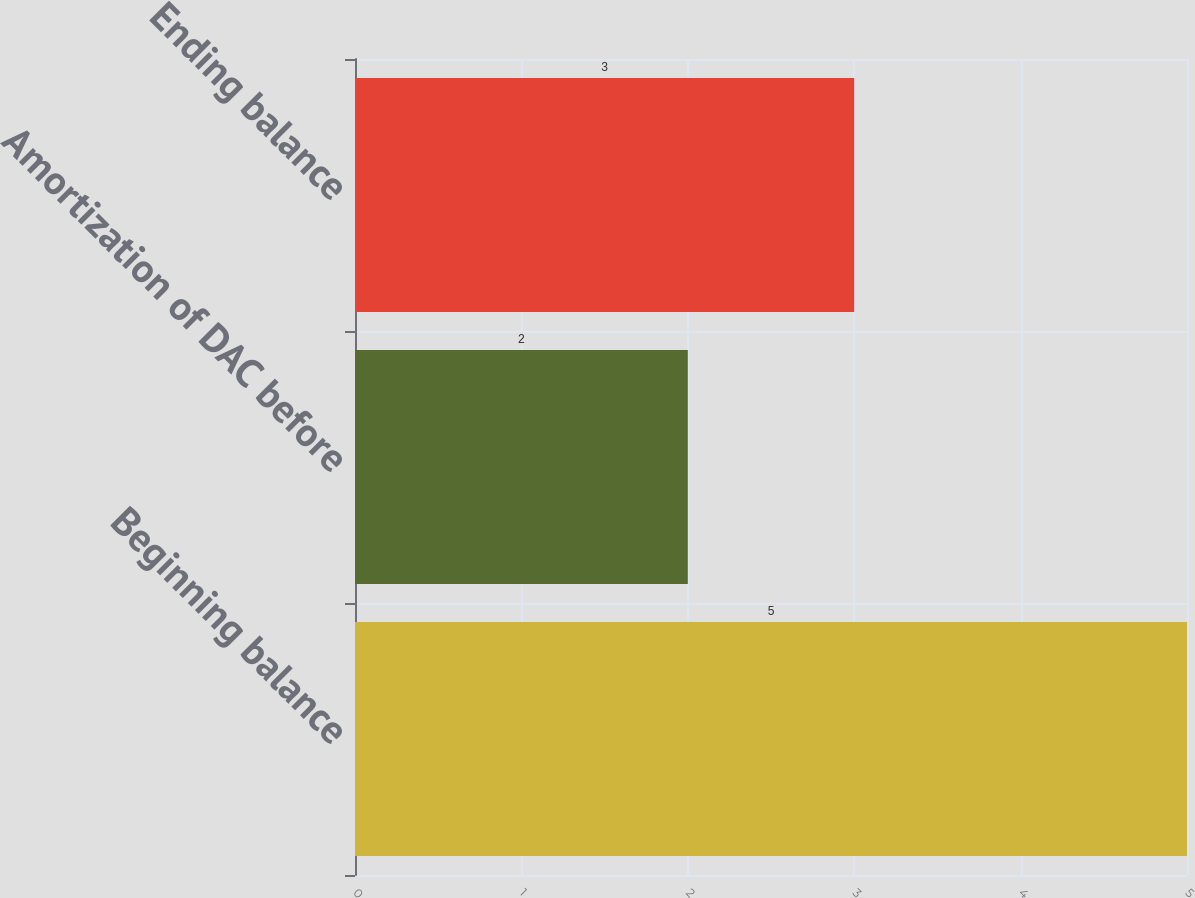<chart> <loc_0><loc_0><loc_500><loc_500><bar_chart><fcel>Beginning balance<fcel>Amortization of DAC before<fcel>Ending balance<nl><fcel>5<fcel>2<fcel>3<nl></chart> 